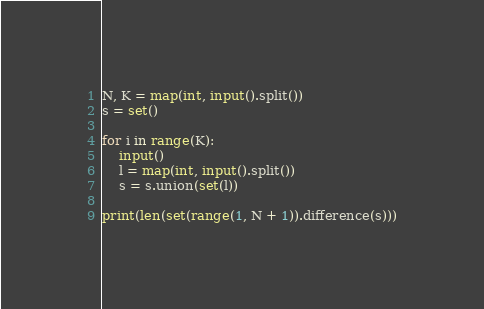Convert code to text. <code><loc_0><loc_0><loc_500><loc_500><_Python_>N, K = map(int, input().split())
s = set()

for i in range(K):
    input()
    l = map(int, input().split())
    s = s.union(set(l))

print(len(set(range(1, N + 1)).difference(s)))
</code> 